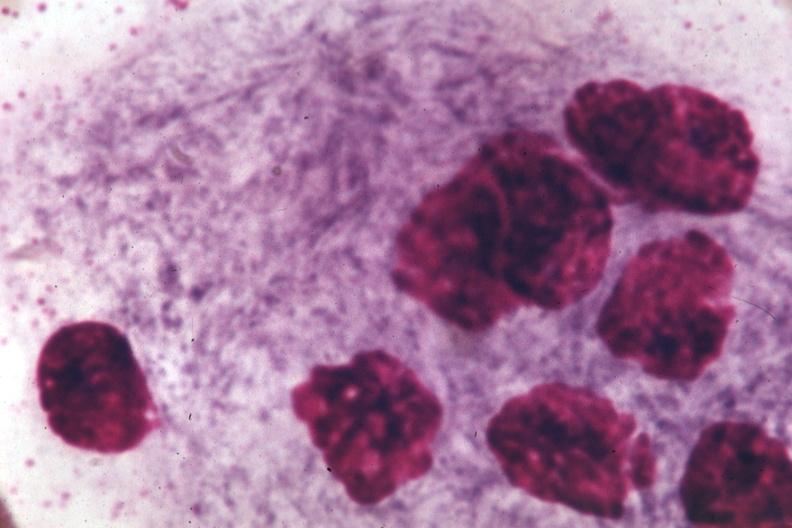what is present?
Answer the question using a single word or phrase. Hematologic 